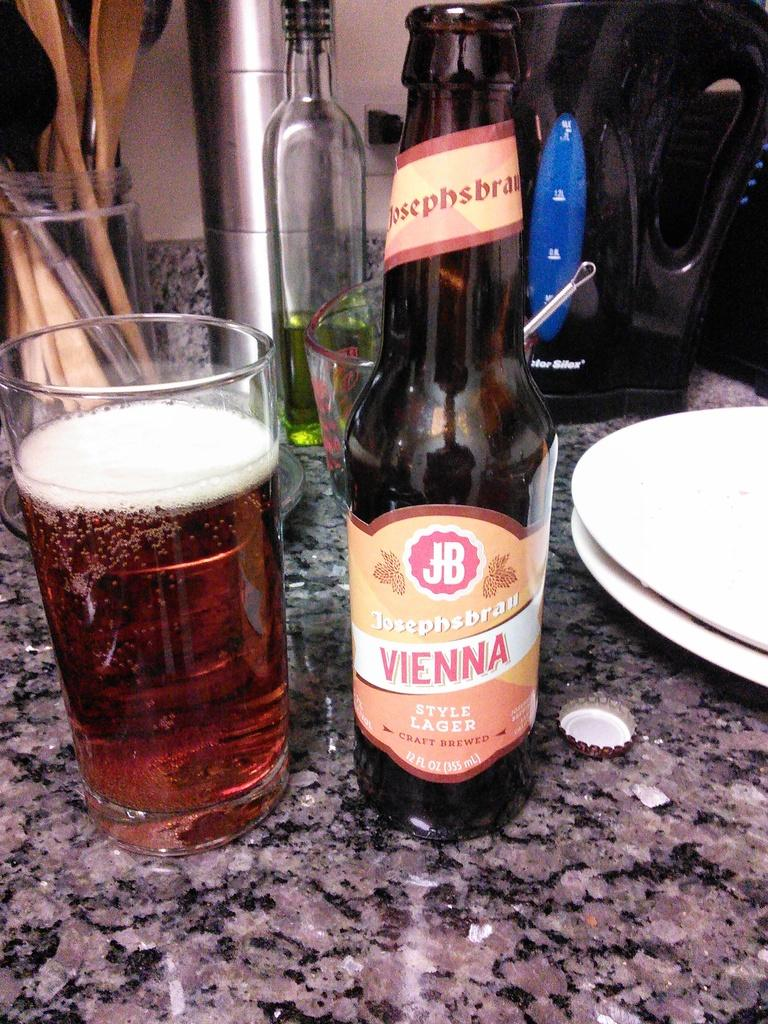<image>
Write a terse but informative summary of the picture. Bottle of Vienna beer next to a cup of ber. 